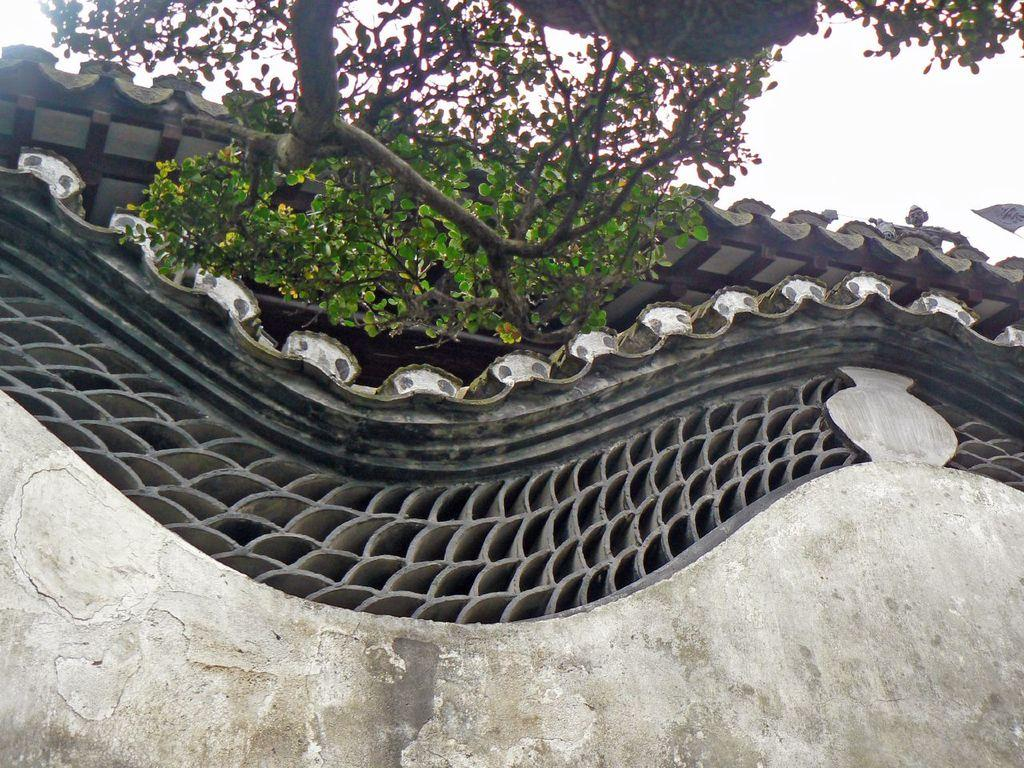What type of structure is visible in the image? There is a building in the image. What natural element is present in the image? There is a tree in the image. How would you describe the sky in the image? The sky is cloudy in the image. What type of wind can be seen blowing the tree in the image? There is no wind visible in the image, and the tree is not shown to be blowing. 